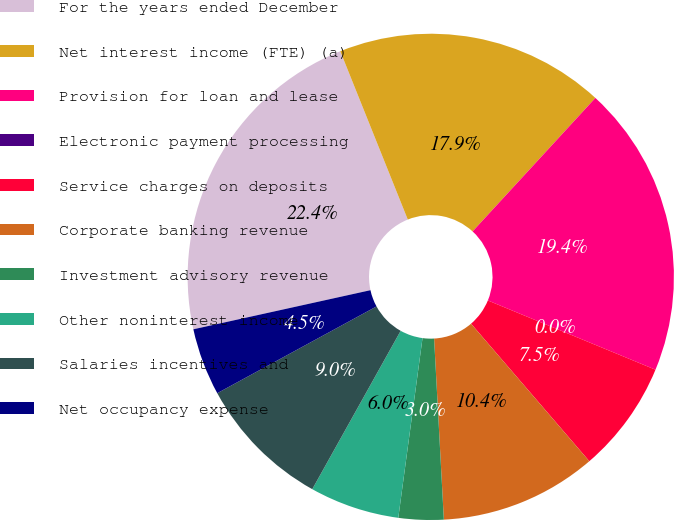<chart> <loc_0><loc_0><loc_500><loc_500><pie_chart><fcel>For the years ended December<fcel>Net interest income (FTE) (a)<fcel>Provision for loan and lease<fcel>Electronic payment processing<fcel>Service charges on deposits<fcel>Corporate banking revenue<fcel>Investment advisory revenue<fcel>Other noninterest income<fcel>Salaries incentives and<fcel>Net occupancy expense<nl><fcel>22.39%<fcel>17.91%<fcel>19.4%<fcel>0.0%<fcel>7.46%<fcel>10.45%<fcel>2.99%<fcel>5.97%<fcel>8.96%<fcel>4.48%<nl></chart> 